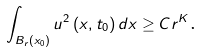Convert formula to latex. <formula><loc_0><loc_0><loc_500><loc_500>\int \nolimits _ { B _ { r } \left ( x _ { 0 } \right ) } u ^ { 2 } \left ( x , t _ { 0 } \right ) d x \geq C r ^ { K } \text {.}</formula> 